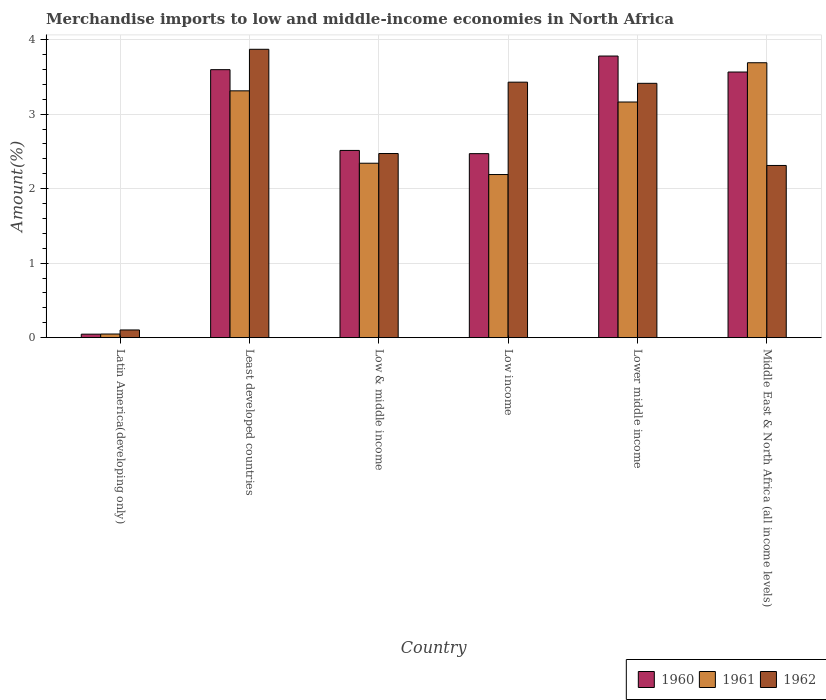How many groups of bars are there?
Your answer should be compact. 6. Are the number of bars on each tick of the X-axis equal?
Offer a very short reply. Yes. How many bars are there on the 6th tick from the left?
Offer a very short reply. 3. What is the label of the 1st group of bars from the left?
Give a very brief answer. Latin America(developing only). In how many cases, is the number of bars for a given country not equal to the number of legend labels?
Provide a short and direct response. 0. What is the percentage of amount earned from merchandise imports in 1961 in Latin America(developing only)?
Keep it short and to the point. 0.05. Across all countries, what is the maximum percentage of amount earned from merchandise imports in 1961?
Offer a very short reply. 3.69. Across all countries, what is the minimum percentage of amount earned from merchandise imports in 1962?
Make the answer very short. 0.1. In which country was the percentage of amount earned from merchandise imports in 1962 maximum?
Give a very brief answer. Least developed countries. In which country was the percentage of amount earned from merchandise imports in 1961 minimum?
Make the answer very short. Latin America(developing only). What is the total percentage of amount earned from merchandise imports in 1961 in the graph?
Your answer should be compact. 14.75. What is the difference between the percentage of amount earned from merchandise imports in 1960 in Least developed countries and that in Low income?
Give a very brief answer. 1.13. What is the difference between the percentage of amount earned from merchandise imports in 1961 in Middle East & North Africa (all income levels) and the percentage of amount earned from merchandise imports in 1960 in Low income?
Your response must be concise. 1.22. What is the average percentage of amount earned from merchandise imports in 1962 per country?
Provide a succinct answer. 2.6. What is the difference between the percentage of amount earned from merchandise imports of/in 1960 and percentage of amount earned from merchandise imports of/in 1962 in Least developed countries?
Provide a short and direct response. -0.27. What is the ratio of the percentage of amount earned from merchandise imports in 1962 in Least developed countries to that in Low income?
Give a very brief answer. 1.13. What is the difference between the highest and the second highest percentage of amount earned from merchandise imports in 1961?
Ensure brevity in your answer.  0.15. What is the difference between the highest and the lowest percentage of amount earned from merchandise imports in 1960?
Your response must be concise. 3.73. In how many countries, is the percentage of amount earned from merchandise imports in 1961 greater than the average percentage of amount earned from merchandise imports in 1961 taken over all countries?
Offer a very short reply. 3. Is the sum of the percentage of amount earned from merchandise imports in 1961 in Latin America(developing only) and Least developed countries greater than the maximum percentage of amount earned from merchandise imports in 1960 across all countries?
Offer a terse response. No. What is the difference between two consecutive major ticks on the Y-axis?
Offer a very short reply. 1. Does the graph contain any zero values?
Ensure brevity in your answer.  No. Does the graph contain grids?
Your answer should be compact. Yes. Where does the legend appear in the graph?
Make the answer very short. Bottom right. How are the legend labels stacked?
Your answer should be very brief. Horizontal. What is the title of the graph?
Provide a short and direct response. Merchandise imports to low and middle-income economies in North Africa. Does "2011" appear as one of the legend labels in the graph?
Ensure brevity in your answer.  No. What is the label or title of the Y-axis?
Provide a short and direct response. Amount(%). What is the Amount(%) in 1960 in Latin America(developing only)?
Keep it short and to the point. 0.05. What is the Amount(%) in 1961 in Latin America(developing only)?
Make the answer very short. 0.05. What is the Amount(%) in 1962 in Latin America(developing only)?
Offer a terse response. 0.1. What is the Amount(%) in 1960 in Least developed countries?
Your answer should be compact. 3.6. What is the Amount(%) in 1961 in Least developed countries?
Make the answer very short. 3.31. What is the Amount(%) of 1962 in Least developed countries?
Your answer should be compact. 3.87. What is the Amount(%) of 1960 in Low & middle income?
Your response must be concise. 2.51. What is the Amount(%) of 1961 in Low & middle income?
Your answer should be very brief. 2.34. What is the Amount(%) in 1962 in Low & middle income?
Make the answer very short. 2.47. What is the Amount(%) of 1960 in Low income?
Your answer should be very brief. 2.47. What is the Amount(%) of 1961 in Low income?
Your answer should be very brief. 2.19. What is the Amount(%) of 1962 in Low income?
Keep it short and to the point. 3.43. What is the Amount(%) of 1960 in Lower middle income?
Give a very brief answer. 3.78. What is the Amount(%) of 1961 in Lower middle income?
Offer a terse response. 3.16. What is the Amount(%) of 1962 in Lower middle income?
Make the answer very short. 3.41. What is the Amount(%) in 1960 in Middle East & North Africa (all income levels)?
Offer a very short reply. 3.57. What is the Amount(%) of 1961 in Middle East & North Africa (all income levels)?
Offer a terse response. 3.69. What is the Amount(%) of 1962 in Middle East & North Africa (all income levels)?
Offer a very short reply. 2.31. Across all countries, what is the maximum Amount(%) in 1960?
Provide a short and direct response. 3.78. Across all countries, what is the maximum Amount(%) in 1961?
Your answer should be very brief. 3.69. Across all countries, what is the maximum Amount(%) in 1962?
Your answer should be compact. 3.87. Across all countries, what is the minimum Amount(%) in 1960?
Your response must be concise. 0.05. Across all countries, what is the minimum Amount(%) in 1961?
Offer a terse response. 0.05. Across all countries, what is the minimum Amount(%) of 1962?
Your answer should be very brief. 0.1. What is the total Amount(%) in 1960 in the graph?
Ensure brevity in your answer.  15.98. What is the total Amount(%) of 1961 in the graph?
Your answer should be compact. 14.75. What is the total Amount(%) of 1962 in the graph?
Provide a short and direct response. 15.6. What is the difference between the Amount(%) of 1960 in Latin America(developing only) and that in Least developed countries?
Your answer should be compact. -3.55. What is the difference between the Amount(%) in 1961 in Latin America(developing only) and that in Least developed countries?
Your answer should be compact. -3.26. What is the difference between the Amount(%) in 1962 in Latin America(developing only) and that in Least developed countries?
Make the answer very short. -3.77. What is the difference between the Amount(%) of 1960 in Latin America(developing only) and that in Low & middle income?
Your answer should be very brief. -2.47. What is the difference between the Amount(%) in 1961 in Latin America(developing only) and that in Low & middle income?
Provide a short and direct response. -2.29. What is the difference between the Amount(%) in 1962 in Latin America(developing only) and that in Low & middle income?
Provide a succinct answer. -2.37. What is the difference between the Amount(%) of 1960 in Latin America(developing only) and that in Low income?
Provide a short and direct response. -2.42. What is the difference between the Amount(%) in 1961 in Latin America(developing only) and that in Low income?
Your response must be concise. -2.14. What is the difference between the Amount(%) in 1962 in Latin America(developing only) and that in Low income?
Provide a succinct answer. -3.33. What is the difference between the Amount(%) of 1960 in Latin America(developing only) and that in Lower middle income?
Keep it short and to the point. -3.73. What is the difference between the Amount(%) in 1961 in Latin America(developing only) and that in Lower middle income?
Ensure brevity in your answer.  -3.12. What is the difference between the Amount(%) of 1962 in Latin America(developing only) and that in Lower middle income?
Provide a short and direct response. -3.31. What is the difference between the Amount(%) in 1960 in Latin America(developing only) and that in Middle East & North Africa (all income levels)?
Provide a succinct answer. -3.52. What is the difference between the Amount(%) in 1961 in Latin America(developing only) and that in Middle East & North Africa (all income levels)?
Ensure brevity in your answer.  -3.64. What is the difference between the Amount(%) in 1962 in Latin America(developing only) and that in Middle East & North Africa (all income levels)?
Ensure brevity in your answer.  -2.21. What is the difference between the Amount(%) in 1960 in Least developed countries and that in Low & middle income?
Provide a short and direct response. 1.08. What is the difference between the Amount(%) of 1961 in Least developed countries and that in Low & middle income?
Ensure brevity in your answer.  0.97. What is the difference between the Amount(%) in 1962 in Least developed countries and that in Low & middle income?
Provide a short and direct response. 1.4. What is the difference between the Amount(%) of 1960 in Least developed countries and that in Low income?
Ensure brevity in your answer.  1.13. What is the difference between the Amount(%) in 1961 in Least developed countries and that in Low income?
Keep it short and to the point. 1.12. What is the difference between the Amount(%) of 1962 in Least developed countries and that in Low income?
Your response must be concise. 0.44. What is the difference between the Amount(%) of 1960 in Least developed countries and that in Lower middle income?
Provide a short and direct response. -0.18. What is the difference between the Amount(%) in 1961 in Least developed countries and that in Lower middle income?
Your answer should be very brief. 0.15. What is the difference between the Amount(%) in 1962 in Least developed countries and that in Lower middle income?
Your answer should be very brief. 0.46. What is the difference between the Amount(%) of 1960 in Least developed countries and that in Middle East & North Africa (all income levels)?
Give a very brief answer. 0.03. What is the difference between the Amount(%) of 1961 in Least developed countries and that in Middle East & North Africa (all income levels)?
Your response must be concise. -0.38. What is the difference between the Amount(%) in 1962 in Least developed countries and that in Middle East & North Africa (all income levels)?
Make the answer very short. 1.56. What is the difference between the Amount(%) in 1960 in Low & middle income and that in Low income?
Provide a short and direct response. 0.04. What is the difference between the Amount(%) in 1961 in Low & middle income and that in Low income?
Provide a succinct answer. 0.15. What is the difference between the Amount(%) of 1962 in Low & middle income and that in Low income?
Provide a short and direct response. -0.96. What is the difference between the Amount(%) of 1960 in Low & middle income and that in Lower middle income?
Ensure brevity in your answer.  -1.27. What is the difference between the Amount(%) of 1961 in Low & middle income and that in Lower middle income?
Offer a very short reply. -0.82. What is the difference between the Amount(%) in 1962 in Low & middle income and that in Lower middle income?
Offer a terse response. -0.94. What is the difference between the Amount(%) in 1960 in Low & middle income and that in Middle East & North Africa (all income levels)?
Keep it short and to the point. -1.05. What is the difference between the Amount(%) in 1961 in Low & middle income and that in Middle East & North Africa (all income levels)?
Ensure brevity in your answer.  -1.35. What is the difference between the Amount(%) in 1962 in Low & middle income and that in Middle East & North Africa (all income levels)?
Provide a succinct answer. 0.16. What is the difference between the Amount(%) of 1960 in Low income and that in Lower middle income?
Your answer should be very brief. -1.31. What is the difference between the Amount(%) of 1961 in Low income and that in Lower middle income?
Give a very brief answer. -0.97. What is the difference between the Amount(%) of 1962 in Low income and that in Lower middle income?
Provide a short and direct response. 0.02. What is the difference between the Amount(%) in 1960 in Low income and that in Middle East & North Africa (all income levels)?
Ensure brevity in your answer.  -1.1. What is the difference between the Amount(%) of 1961 in Low income and that in Middle East & North Africa (all income levels)?
Keep it short and to the point. -1.5. What is the difference between the Amount(%) of 1962 in Low income and that in Middle East & North Africa (all income levels)?
Your answer should be compact. 1.12. What is the difference between the Amount(%) of 1960 in Lower middle income and that in Middle East & North Africa (all income levels)?
Your response must be concise. 0.21. What is the difference between the Amount(%) of 1961 in Lower middle income and that in Middle East & North Africa (all income levels)?
Your response must be concise. -0.53. What is the difference between the Amount(%) in 1962 in Lower middle income and that in Middle East & North Africa (all income levels)?
Make the answer very short. 1.1. What is the difference between the Amount(%) in 1960 in Latin America(developing only) and the Amount(%) in 1961 in Least developed countries?
Make the answer very short. -3.27. What is the difference between the Amount(%) in 1960 in Latin America(developing only) and the Amount(%) in 1962 in Least developed countries?
Provide a short and direct response. -3.82. What is the difference between the Amount(%) of 1961 in Latin America(developing only) and the Amount(%) of 1962 in Least developed countries?
Keep it short and to the point. -3.82. What is the difference between the Amount(%) in 1960 in Latin America(developing only) and the Amount(%) in 1961 in Low & middle income?
Your response must be concise. -2.29. What is the difference between the Amount(%) of 1960 in Latin America(developing only) and the Amount(%) of 1962 in Low & middle income?
Provide a succinct answer. -2.43. What is the difference between the Amount(%) of 1961 in Latin America(developing only) and the Amount(%) of 1962 in Low & middle income?
Your answer should be very brief. -2.42. What is the difference between the Amount(%) in 1960 in Latin America(developing only) and the Amount(%) in 1961 in Low income?
Offer a terse response. -2.14. What is the difference between the Amount(%) in 1960 in Latin America(developing only) and the Amount(%) in 1962 in Low income?
Your answer should be very brief. -3.38. What is the difference between the Amount(%) in 1961 in Latin America(developing only) and the Amount(%) in 1962 in Low income?
Ensure brevity in your answer.  -3.38. What is the difference between the Amount(%) in 1960 in Latin America(developing only) and the Amount(%) in 1961 in Lower middle income?
Your answer should be compact. -3.12. What is the difference between the Amount(%) in 1960 in Latin America(developing only) and the Amount(%) in 1962 in Lower middle income?
Your response must be concise. -3.37. What is the difference between the Amount(%) in 1961 in Latin America(developing only) and the Amount(%) in 1962 in Lower middle income?
Ensure brevity in your answer.  -3.37. What is the difference between the Amount(%) in 1960 in Latin America(developing only) and the Amount(%) in 1961 in Middle East & North Africa (all income levels)?
Give a very brief answer. -3.64. What is the difference between the Amount(%) of 1960 in Latin America(developing only) and the Amount(%) of 1962 in Middle East & North Africa (all income levels)?
Ensure brevity in your answer.  -2.27. What is the difference between the Amount(%) of 1961 in Latin America(developing only) and the Amount(%) of 1962 in Middle East & North Africa (all income levels)?
Provide a succinct answer. -2.26. What is the difference between the Amount(%) in 1960 in Least developed countries and the Amount(%) in 1961 in Low & middle income?
Your answer should be very brief. 1.26. What is the difference between the Amount(%) in 1960 in Least developed countries and the Amount(%) in 1962 in Low & middle income?
Offer a very short reply. 1.13. What is the difference between the Amount(%) in 1961 in Least developed countries and the Amount(%) in 1962 in Low & middle income?
Offer a very short reply. 0.84. What is the difference between the Amount(%) in 1960 in Least developed countries and the Amount(%) in 1961 in Low income?
Your response must be concise. 1.41. What is the difference between the Amount(%) of 1960 in Least developed countries and the Amount(%) of 1962 in Low income?
Ensure brevity in your answer.  0.17. What is the difference between the Amount(%) of 1961 in Least developed countries and the Amount(%) of 1962 in Low income?
Give a very brief answer. -0.12. What is the difference between the Amount(%) of 1960 in Least developed countries and the Amount(%) of 1961 in Lower middle income?
Provide a succinct answer. 0.43. What is the difference between the Amount(%) in 1960 in Least developed countries and the Amount(%) in 1962 in Lower middle income?
Provide a short and direct response. 0.18. What is the difference between the Amount(%) of 1961 in Least developed countries and the Amount(%) of 1962 in Lower middle income?
Your answer should be very brief. -0.1. What is the difference between the Amount(%) in 1960 in Least developed countries and the Amount(%) in 1961 in Middle East & North Africa (all income levels)?
Your answer should be very brief. -0.09. What is the difference between the Amount(%) in 1960 in Least developed countries and the Amount(%) in 1962 in Middle East & North Africa (all income levels)?
Offer a terse response. 1.29. What is the difference between the Amount(%) in 1960 in Low & middle income and the Amount(%) in 1961 in Low income?
Give a very brief answer. 0.32. What is the difference between the Amount(%) in 1960 in Low & middle income and the Amount(%) in 1962 in Low income?
Make the answer very short. -0.92. What is the difference between the Amount(%) in 1961 in Low & middle income and the Amount(%) in 1962 in Low income?
Your response must be concise. -1.09. What is the difference between the Amount(%) of 1960 in Low & middle income and the Amount(%) of 1961 in Lower middle income?
Your answer should be compact. -0.65. What is the difference between the Amount(%) in 1960 in Low & middle income and the Amount(%) in 1962 in Lower middle income?
Offer a terse response. -0.9. What is the difference between the Amount(%) in 1961 in Low & middle income and the Amount(%) in 1962 in Lower middle income?
Ensure brevity in your answer.  -1.07. What is the difference between the Amount(%) in 1960 in Low & middle income and the Amount(%) in 1961 in Middle East & North Africa (all income levels)?
Make the answer very short. -1.18. What is the difference between the Amount(%) in 1960 in Low & middle income and the Amount(%) in 1962 in Middle East & North Africa (all income levels)?
Offer a very short reply. 0.2. What is the difference between the Amount(%) of 1960 in Low income and the Amount(%) of 1961 in Lower middle income?
Ensure brevity in your answer.  -0.69. What is the difference between the Amount(%) in 1960 in Low income and the Amount(%) in 1962 in Lower middle income?
Your answer should be compact. -0.94. What is the difference between the Amount(%) in 1961 in Low income and the Amount(%) in 1962 in Lower middle income?
Give a very brief answer. -1.22. What is the difference between the Amount(%) of 1960 in Low income and the Amount(%) of 1961 in Middle East & North Africa (all income levels)?
Provide a succinct answer. -1.22. What is the difference between the Amount(%) in 1960 in Low income and the Amount(%) in 1962 in Middle East & North Africa (all income levels)?
Make the answer very short. 0.16. What is the difference between the Amount(%) of 1961 in Low income and the Amount(%) of 1962 in Middle East & North Africa (all income levels)?
Your response must be concise. -0.12. What is the difference between the Amount(%) in 1960 in Lower middle income and the Amount(%) in 1961 in Middle East & North Africa (all income levels)?
Your answer should be compact. 0.09. What is the difference between the Amount(%) of 1960 in Lower middle income and the Amount(%) of 1962 in Middle East & North Africa (all income levels)?
Offer a very short reply. 1.47. What is the difference between the Amount(%) in 1961 in Lower middle income and the Amount(%) in 1962 in Middle East & North Africa (all income levels)?
Your response must be concise. 0.85. What is the average Amount(%) of 1960 per country?
Provide a succinct answer. 2.66. What is the average Amount(%) in 1961 per country?
Ensure brevity in your answer.  2.46. What is the average Amount(%) in 1962 per country?
Offer a terse response. 2.6. What is the difference between the Amount(%) of 1960 and Amount(%) of 1961 in Latin America(developing only)?
Offer a very short reply. -0. What is the difference between the Amount(%) of 1960 and Amount(%) of 1962 in Latin America(developing only)?
Provide a short and direct response. -0.06. What is the difference between the Amount(%) in 1961 and Amount(%) in 1962 in Latin America(developing only)?
Your answer should be very brief. -0.05. What is the difference between the Amount(%) in 1960 and Amount(%) in 1961 in Least developed countries?
Make the answer very short. 0.28. What is the difference between the Amount(%) of 1960 and Amount(%) of 1962 in Least developed countries?
Offer a terse response. -0.27. What is the difference between the Amount(%) of 1961 and Amount(%) of 1962 in Least developed countries?
Provide a short and direct response. -0.56. What is the difference between the Amount(%) of 1960 and Amount(%) of 1961 in Low & middle income?
Offer a terse response. 0.17. What is the difference between the Amount(%) in 1960 and Amount(%) in 1962 in Low & middle income?
Ensure brevity in your answer.  0.04. What is the difference between the Amount(%) in 1961 and Amount(%) in 1962 in Low & middle income?
Ensure brevity in your answer.  -0.13. What is the difference between the Amount(%) in 1960 and Amount(%) in 1961 in Low income?
Offer a very short reply. 0.28. What is the difference between the Amount(%) in 1960 and Amount(%) in 1962 in Low income?
Your answer should be compact. -0.96. What is the difference between the Amount(%) of 1961 and Amount(%) of 1962 in Low income?
Offer a terse response. -1.24. What is the difference between the Amount(%) in 1960 and Amount(%) in 1961 in Lower middle income?
Make the answer very short. 0.62. What is the difference between the Amount(%) in 1960 and Amount(%) in 1962 in Lower middle income?
Your answer should be compact. 0.37. What is the difference between the Amount(%) of 1961 and Amount(%) of 1962 in Lower middle income?
Your answer should be very brief. -0.25. What is the difference between the Amount(%) in 1960 and Amount(%) in 1961 in Middle East & North Africa (all income levels)?
Your answer should be compact. -0.12. What is the difference between the Amount(%) of 1960 and Amount(%) of 1962 in Middle East & North Africa (all income levels)?
Make the answer very short. 1.25. What is the difference between the Amount(%) in 1961 and Amount(%) in 1962 in Middle East & North Africa (all income levels)?
Your answer should be compact. 1.38. What is the ratio of the Amount(%) of 1960 in Latin America(developing only) to that in Least developed countries?
Keep it short and to the point. 0.01. What is the ratio of the Amount(%) of 1961 in Latin America(developing only) to that in Least developed countries?
Keep it short and to the point. 0.01. What is the ratio of the Amount(%) of 1962 in Latin America(developing only) to that in Least developed countries?
Your answer should be very brief. 0.03. What is the ratio of the Amount(%) in 1960 in Latin America(developing only) to that in Low & middle income?
Give a very brief answer. 0.02. What is the ratio of the Amount(%) in 1961 in Latin America(developing only) to that in Low & middle income?
Keep it short and to the point. 0.02. What is the ratio of the Amount(%) of 1962 in Latin America(developing only) to that in Low & middle income?
Give a very brief answer. 0.04. What is the ratio of the Amount(%) of 1960 in Latin America(developing only) to that in Low income?
Your response must be concise. 0.02. What is the ratio of the Amount(%) of 1961 in Latin America(developing only) to that in Low income?
Provide a succinct answer. 0.02. What is the ratio of the Amount(%) of 1962 in Latin America(developing only) to that in Low income?
Provide a succinct answer. 0.03. What is the ratio of the Amount(%) in 1960 in Latin America(developing only) to that in Lower middle income?
Offer a terse response. 0.01. What is the ratio of the Amount(%) in 1961 in Latin America(developing only) to that in Lower middle income?
Make the answer very short. 0.02. What is the ratio of the Amount(%) of 1962 in Latin America(developing only) to that in Lower middle income?
Your response must be concise. 0.03. What is the ratio of the Amount(%) of 1960 in Latin America(developing only) to that in Middle East & North Africa (all income levels)?
Offer a terse response. 0.01. What is the ratio of the Amount(%) in 1961 in Latin America(developing only) to that in Middle East & North Africa (all income levels)?
Keep it short and to the point. 0.01. What is the ratio of the Amount(%) of 1962 in Latin America(developing only) to that in Middle East & North Africa (all income levels)?
Offer a very short reply. 0.04. What is the ratio of the Amount(%) of 1960 in Least developed countries to that in Low & middle income?
Make the answer very short. 1.43. What is the ratio of the Amount(%) of 1961 in Least developed countries to that in Low & middle income?
Ensure brevity in your answer.  1.42. What is the ratio of the Amount(%) in 1962 in Least developed countries to that in Low & middle income?
Provide a short and direct response. 1.57. What is the ratio of the Amount(%) in 1960 in Least developed countries to that in Low income?
Your response must be concise. 1.46. What is the ratio of the Amount(%) of 1961 in Least developed countries to that in Low income?
Ensure brevity in your answer.  1.51. What is the ratio of the Amount(%) of 1962 in Least developed countries to that in Low income?
Your response must be concise. 1.13. What is the ratio of the Amount(%) of 1960 in Least developed countries to that in Lower middle income?
Offer a very short reply. 0.95. What is the ratio of the Amount(%) of 1961 in Least developed countries to that in Lower middle income?
Your answer should be very brief. 1.05. What is the ratio of the Amount(%) of 1962 in Least developed countries to that in Lower middle income?
Ensure brevity in your answer.  1.13. What is the ratio of the Amount(%) in 1960 in Least developed countries to that in Middle East & North Africa (all income levels)?
Keep it short and to the point. 1.01. What is the ratio of the Amount(%) of 1961 in Least developed countries to that in Middle East & North Africa (all income levels)?
Offer a terse response. 0.9. What is the ratio of the Amount(%) in 1962 in Least developed countries to that in Middle East & North Africa (all income levels)?
Your response must be concise. 1.67. What is the ratio of the Amount(%) in 1960 in Low & middle income to that in Low income?
Your answer should be very brief. 1.02. What is the ratio of the Amount(%) of 1961 in Low & middle income to that in Low income?
Keep it short and to the point. 1.07. What is the ratio of the Amount(%) of 1962 in Low & middle income to that in Low income?
Offer a very short reply. 0.72. What is the ratio of the Amount(%) of 1960 in Low & middle income to that in Lower middle income?
Your response must be concise. 0.66. What is the ratio of the Amount(%) of 1961 in Low & middle income to that in Lower middle income?
Your response must be concise. 0.74. What is the ratio of the Amount(%) in 1962 in Low & middle income to that in Lower middle income?
Your answer should be very brief. 0.72. What is the ratio of the Amount(%) of 1960 in Low & middle income to that in Middle East & North Africa (all income levels)?
Offer a terse response. 0.7. What is the ratio of the Amount(%) of 1961 in Low & middle income to that in Middle East & North Africa (all income levels)?
Make the answer very short. 0.63. What is the ratio of the Amount(%) of 1962 in Low & middle income to that in Middle East & North Africa (all income levels)?
Ensure brevity in your answer.  1.07. What is the ratio of the Amount(%) of 1960 in Low income to that in Lower middle income?
Give a very brief answer. 0.65. What is the ratio of the Amount(%) in 1961 in Low income to that in Lower middle income?
Your answer should be compact. 0.69. What is the ratio of the Amount(%) in 1962 in Low income to that in Lower middle income?
Give a very brief answer. 1. What is the ratio of the Amount(%) in 1960 in Low income to that in Middle East & North Africa (all income levels)?
Give a very brief answer. 0.69. What is the ratio of the Amount(%) in 1961 in Low income to that in Middle East & North Africa (all income levels)?
Offer a terse response. 0.59. What is the ratio of the Amount(%) in 1962 in Low income to that in Middle East & North Africa (all income levels)?
Your response must be concise. 1.48. What is the ratio of the Amount(%) of 1960 in Lower middle income to that in Middle East & North Africa (all income levels)?
Offer a very short reply. 1.06. What is the ratio of the Amount(%) of 1961 in Lower middle income to that in Middle East & North Africa (all income levels)?
Provide a succinct answer. 0.86. What is the ratio of the Amount(%) of 1962 in Lower middle income to that in Middle East & North Africa (all income levels)?
Keep it short and to the point. 1.48. What is the difference between the highest and the second highest Amount(%) in 1960?
Keep it short and to the point. 0.18. What is the difference between the highest and the second highest Amount(%) in 1961?
Provide a succinct answer. 0.38. What is the difference between the highest and the second highest Amount(%) of 1962?
Keep it short and to the point. 0.44. What is the difference between the highest and the lowest Amount(%) of 1960?
Ensure brevity in your answer.  3.73. What is the difference between the highest and the lowest Amount(%) of 1961?
Give a very brief answer. 3.64. What is the difference between the highest and the lowest Amount(%) in 1962?
Your answer should be compact. 3.77. 